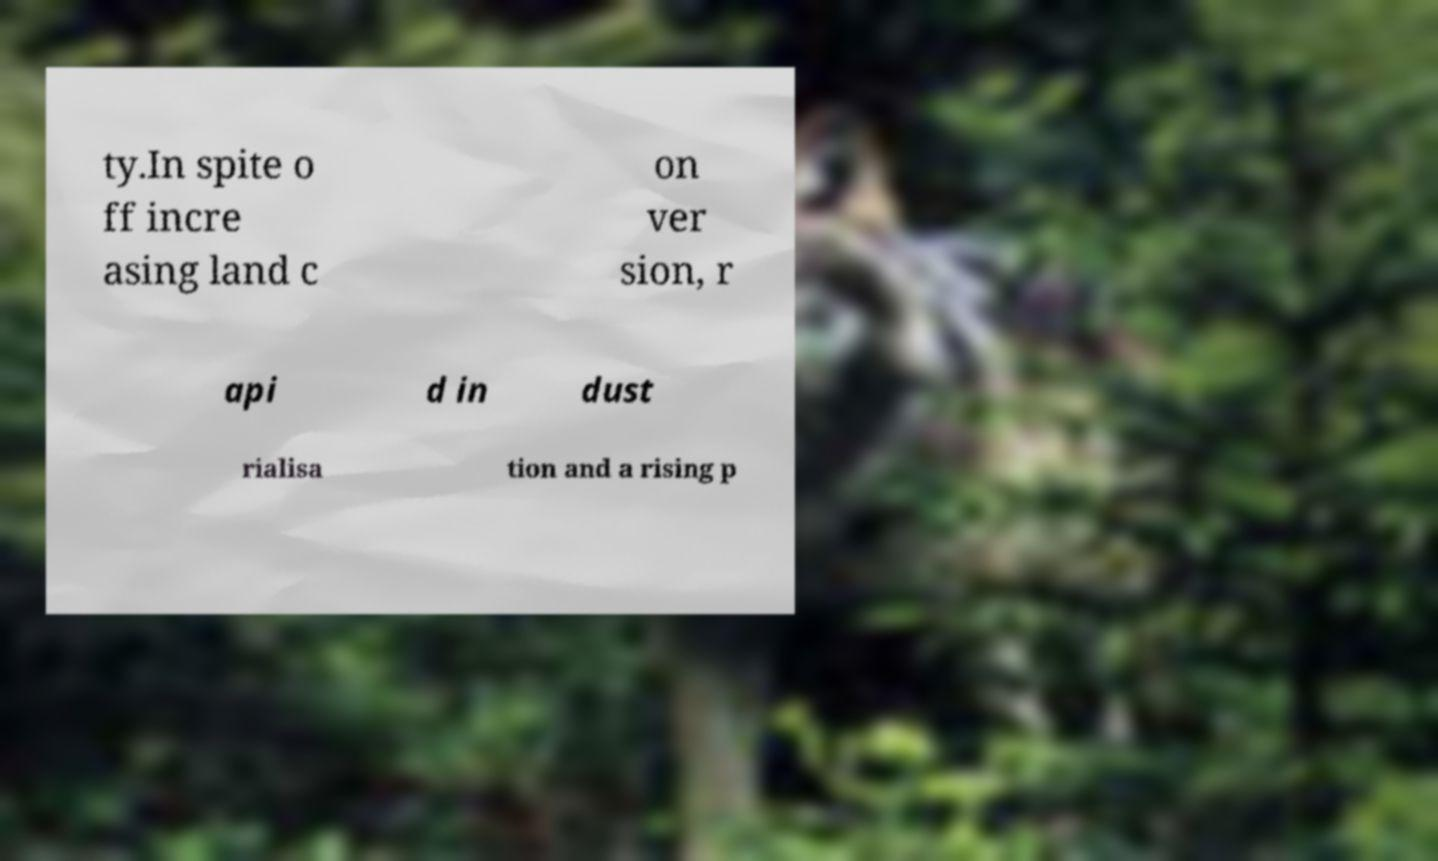Please identify and transcribe the text found in this image. ty.In spite o ff incre asing land c on ver sion, r api d in dust rialisa tion and a rising p 